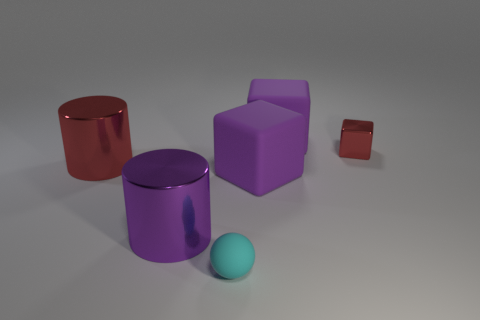How many other things are made of the same material as the cyan thing?
Your answer should be very brief. 2. There is a thing that is the same size as the red cube; what is it made of?
Offer a very short reply. Rubber. Is the number of big purple objects that are behind the big red metal cylinder less than the number of large cylinders?
Provide a succinct answer. Yes. What shape is the large thing that is in front of the purple matte thing in front of the big metallic cylinder that is behind the purple shiny thing?
Make the answer very short. Cylinder. What is the size of the red metallic thing on the right side of the big red metal cylinder?
Provide a succinct answer. Small. What is the shape of the red metal object that is the same size as the purple shiny object?
Offer a very short reply. Cylinder. How many things are large purple shiny cylinders or purple rubber blocks behind the large red metal object?
Your response must be concise. 2. What number of large blocks are left of the large purple rubber cube that is in front of the large purple thing behind the small metallic object?
Offer a terse response. 0. The other big cylinder that is made of the same material as the large red cylinder is what color?
Give a very brief answer. Purple. Is the size of the red thing on the left side of the cyan rubber sphere the same as the tiny red metal block?
Make the answer very short. No. 